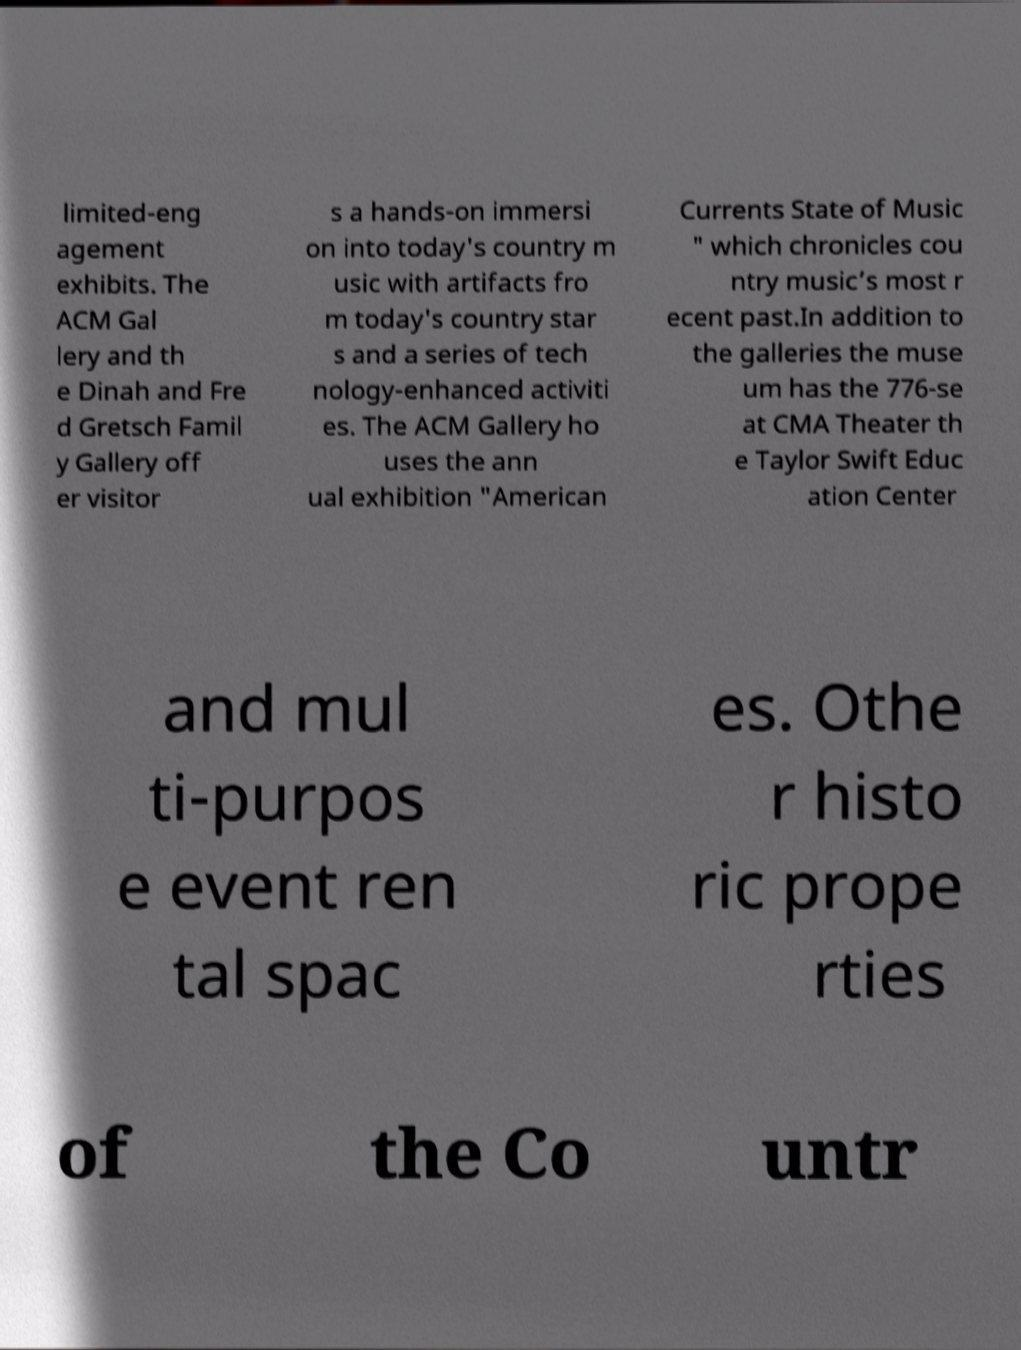There's text embedded in this image that I need extracted. Can you transcribe it verbatim? limited-eng agement exhibits. The ACM Gal lery and th e Dinah and Fre d Gretsch Famil y Gallery off er visitor s a hands-on immersi on into today's country m usic with artifacts fro m today's country star s and a series of tech nology-enhanced activiti es. The ACM Gallery ho uses the ann ual exhibition "American Currents State of Music " which chronicles cou ntry music’s most r ecent past.In addition to the galleries the muse um has the 776-se at CMA Theater th e Taylor Swift Educ ation Center and mul ti-purpos e event ren tal spac es. Othe r histo ric prope rties of the Co untr 